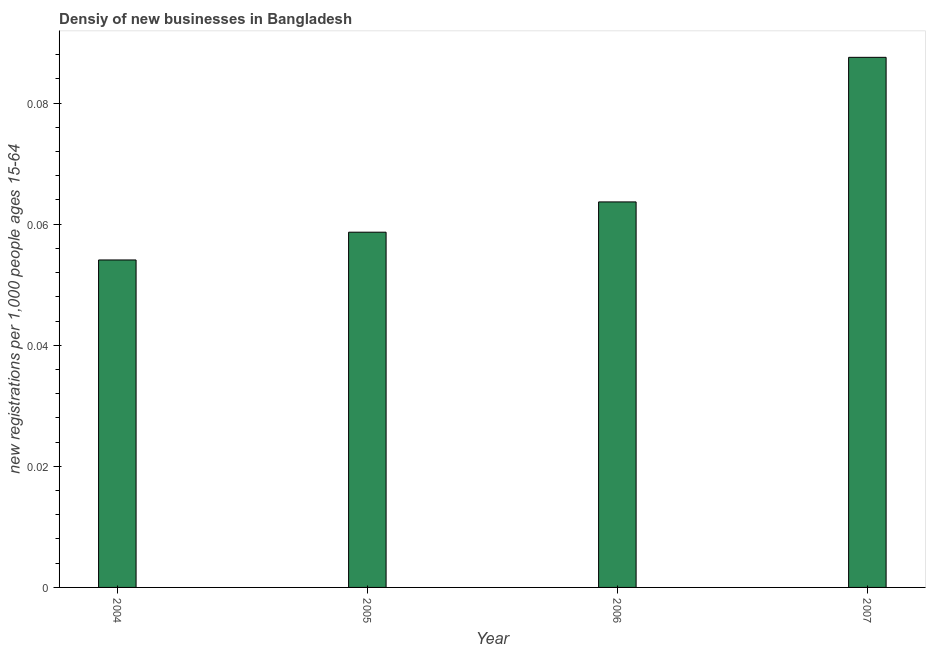Does the graph contain any zero values?
Ensure brevity in your answer.  No. What is the title of the graph?
Your answer should be very brief. Densiy of new businesses in Bangladesh. What is the label or title of the X-axis?
Offer a very short reply. Year. What is the label or title of the Y-axis?
Your response must be concise. New registrations per 1,0 people ages 15-64. What is the density of new business in 2005?
Your response must be concise. 0.06. Across all years, what is the maximum density of new business?
Provide a succinct answer. 0.09. Across all years, what is the minimum density of new business?
Keep it short and to the point. 0.05. What is the sum of the density of new business?
Your answer should be compact. 0.26. What is the difference between the density of new business in 2005 and 2006?
Give a very brief answer. -0.01. What is the average density of new business per year?
Provide a succinct answer. 0.07. What is the median density of new business?
Provide a succinct answer. 0.06. In how many years, is the density of new business greater than 0.004 ?
Offer a terse response. 4. Do a majority of the years between 2007 and 2005 (inclusive) have density of new business greater than 0.056 ?
Your response must be concise. Yes. What is the ratio of the density of new business in 2004 to that in 2005?
Offer a terse response. 0.92. Is the difference between the density of new business in 2004 and 2006 greater than the difference between any two years?
Your answer should be compact. No. What is the difference between the highest and the second highest density of new business?
Your response must be concise. 0.02. What is the difference between the highest and the lowest density of new business?
Your answer should be compact. 0.03. Are all the bars in the graph horizontal?
Provide a succinct answer. No. What is the difference between two consecutive major ticks on the Y-axis?
Give a very brief answer. 0.02. Are the values on the major ticks of Y-axis written in scientific E-notation?
Give a very brief answer. No. What is the new registrations per 1,000 people ages 15-64 of 2004?
Offer a terse response. 0.05. What is the new registrations per 1,000 people ages 15-64 of 2005?
Your answer should be compact. 0.06. What is the new registrations per 1,000 people ages 15-64 in 2006?
Keep it short and to the point. 0.06. What is the new registrations per 1,000 people ages 15-64 of 2007?
Your response must be concise. 0.09. What is the difference between the new registrations per 1,000 people ages 15-64 in 2004 and 2005?
Your response must be concise. -0. What is the difference between the new registrations per 1,000 people ages 15-64 in 2004 and 2006?
Your answer should be compact. -0.01. What is the difference between the new registrations per 1,000 people ages 15-64 in 2004 and 2007?
Your answer should be compact. -0.03. What is the difference between the new registrations per 1,000 people ages 15-64 in 2005 and 2006?
Your answer should be compact. -0.01. What is the difference between the new registrations per 1,000 people ages 15-64 in 2005 and 2007?
Your response must be concise. -0.03. What is the difference between the new registrations per 1,000 people ages 15-64 in 2006 and 2007?
Give a very brief answer. -0.02. What is the ratio of the new registrations per 1,000 people ages 15-64 in 2004 to that in 2005?
Keep it short and to the point. 0.92. What is the ratio of the new registrations per 1,000 people ages 15-64 in 2004 to that in 2006?
Offer a terse response. 0.85. What is the ratio of the new registrations per 1,000 people ages 15-64 in 2004 to that in 2007?
Offer a very short reply. 0.62. What is the ratio of the new registrations per 1,000 people ages 15-64 in 2005 to that in 2006?
Provide a succinct answer. 0.92. What is the ratio of the new registrations per 1,000 people ages 15-64 in 2005 to that in 2007?
Ensure brevity in your answer.  0.67. What is the ratio of the new registrations per 1,000 people ages 15-64 in 2006 to that in 2007?
Offer a terse response. 0.73. 